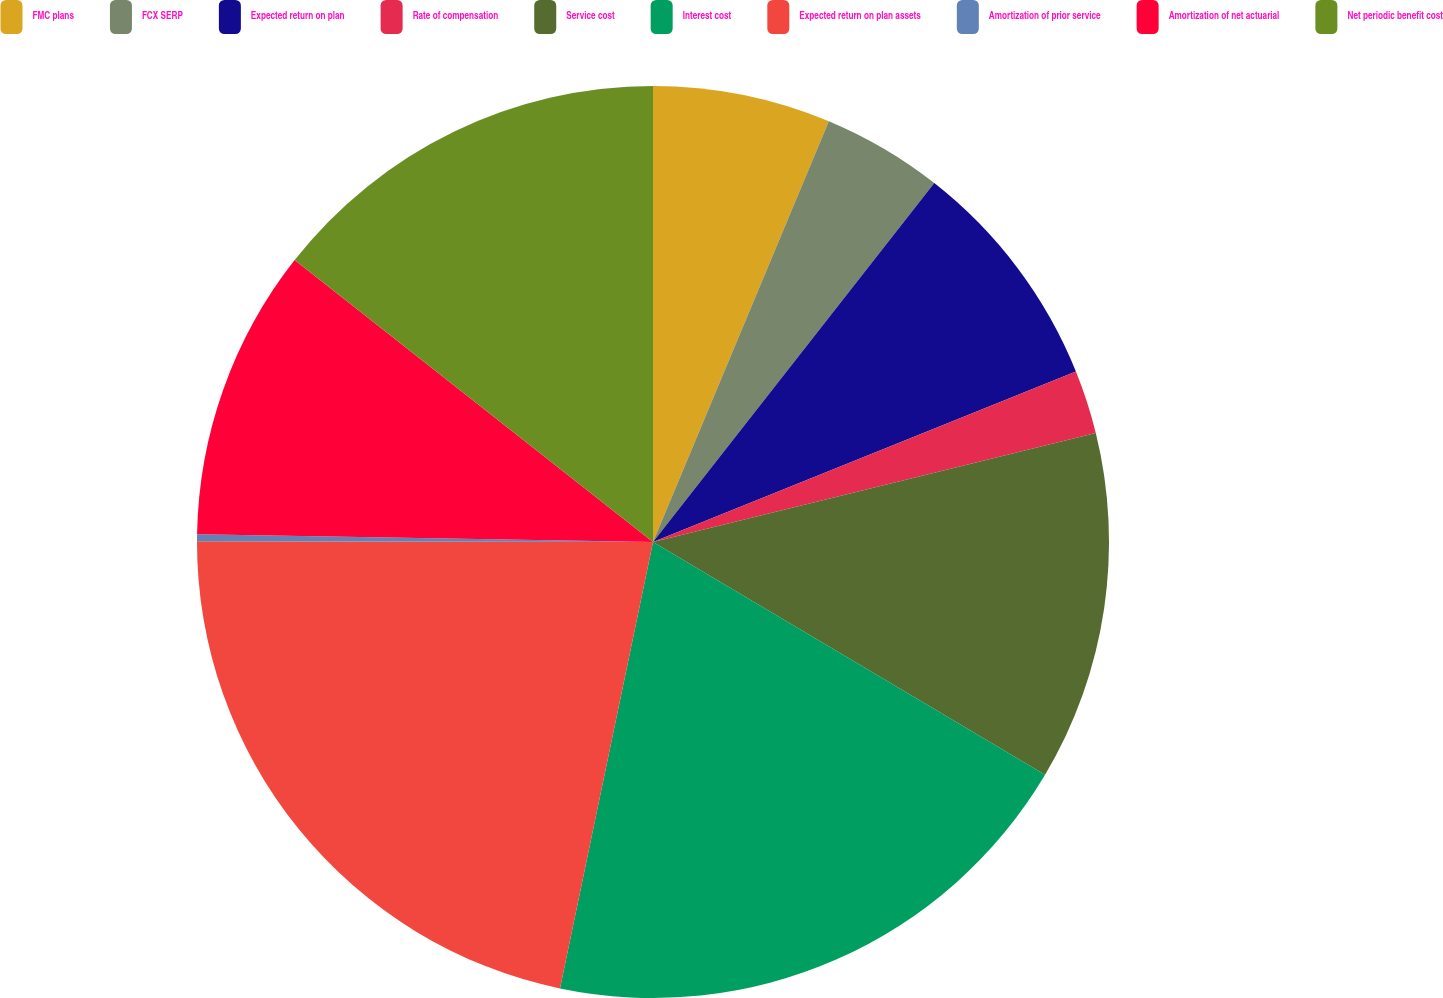<chart> <loc_0><loc_0><loc_500><loc_500><pie_chart><fcel>FMC plans<fcel>FCX SERP<fcel>Expected return on plan<fcel>Rate of compensation<fcel>Service cost<fcel>Interest cost<fcel>Expected return on plan assets<fcel>Amortization of prior service<fcel>Amortization of net actuarial<fcel>Net periodic benefit cost<nl><fcel>6.3%<fcel>4.28%<fcel>8.32%<fcel>2.26%<fcel>12.37%<fcel>19.74%<fcel>21.76%<fcel>0.24%<fcel>10.34%<fcel>14.39%<nl></chart> 